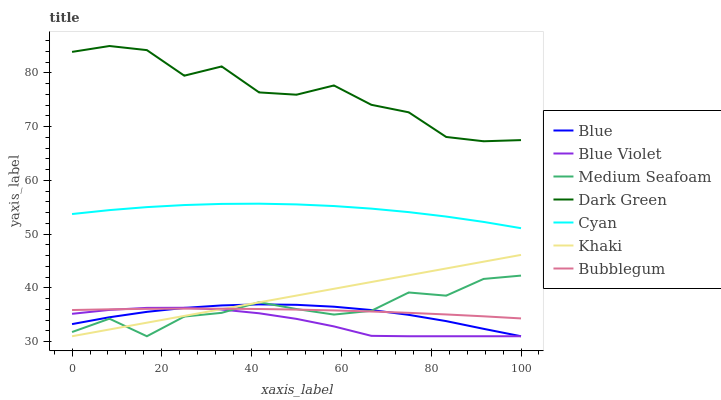Does Khaki have the minimum area under the curve?
Answer yes or no. No. Does Khaki have the maximum area under the curve?
Answer yes or no. No. Is Bubblegum the smoothest?
Answer yes or no. No. Is Bubblegum the roughest?
Answer yes or no. No. Does Bubblegum have the lowest value?
Answer yes or no. No. Does Khaki have the highest value?
Answer yes or no. No. Is Medium Seafoam less than Cyan?
Answer yes or no. Yes. Is Dark Green greater than Khaki?
Answer yes or no. Yes. Does Medium Seafoam intersect Cyan?
Answer yes or no. No. 